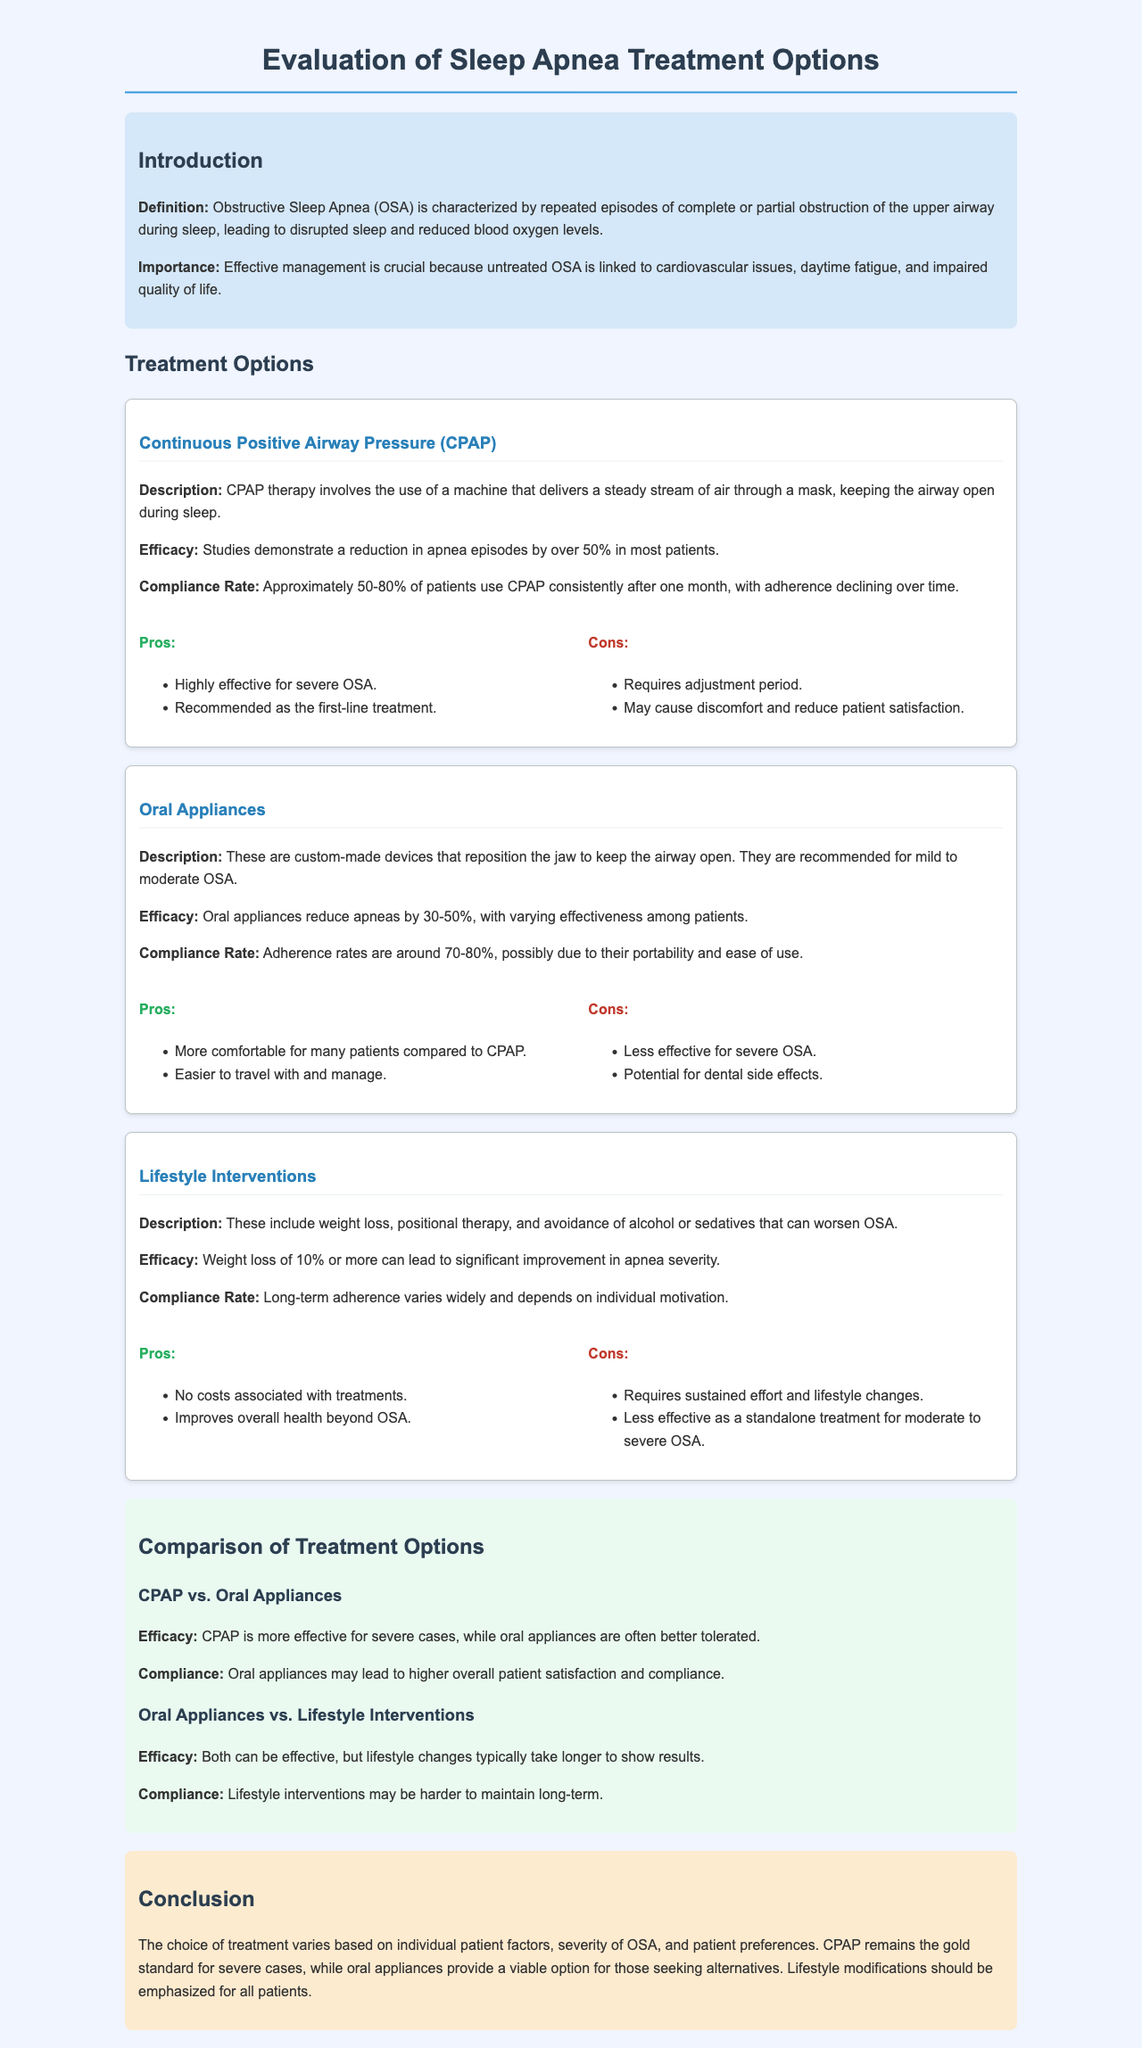What is the definition of Obstructive Sleep Apnea? The definition of Obstructive Sleep Apnea is characterized by repeated episodes of complete or partial obstruction of the upper airway during sleep.
Answer: repeated episodes of complete or partial obstruction of the upper airway during sleep What is the compliance rate for CPAP therapy after one month? The document states that approximately 50-80% of patients use CPAP consistently after one month.
Answer: 50-80% What are the pros of using Oral Appliances? The document provides the pros of Oral Appliances, which include being more comfortable compared to CPAP and easier to travel with.
Answer: more comfortable; easier to travel with How much can weight loss improve apnea severity? The report indicates that a weight loss of 10% or more can lead to significant improvement in apnea severity.
Answer: 10% Which treatment is considered the gold standard for severe cases of OSA? The conclusion section states that CPAP remains the gold standard for severe cases.
Answer: CPAP What is the efficacy comparison between CPAP and Oral Appliances for severe cases? The document states that CPAP is more effective for severe cases, while oral appliances are often better tolerated.
Answer: CPAP is more effective What are the cons of Lifestyle Interventions? The document outlines two cons: requires sustained effort and lifestyle changes, and less effective as a standalone treatment for moderate to severe OSA.
Answer: requires sustained effort and lifestyle changes; less effective as a standalone treatment What is a key reason patients may prefer Oral Appliances over CPAP? The higher overall patient satisfaction and compliance associated with Oral Appliances may contribute to patient preference.
Answer: higher overall patient satisfaction and compliance What is indicated about long-term adherence to Lifestyle Interventions? Long-term adherence varies widely and depends on individual motivation as mentioned in the section on Lifestyle Interventions.
Answer: varies widely; depends on individual motivation 